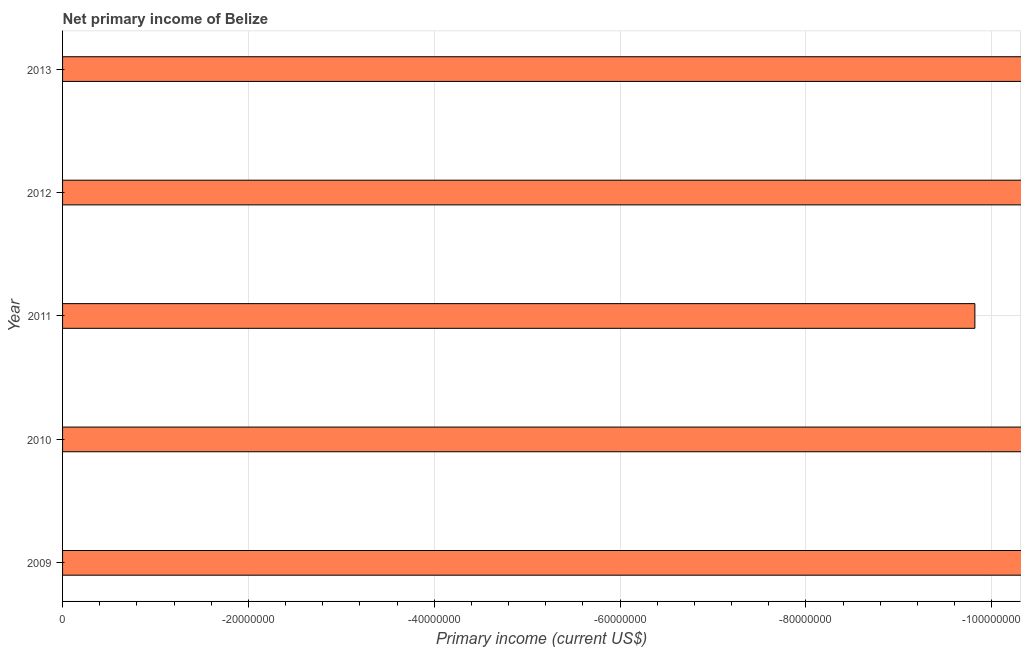Does the graph contain any zero values?
Your answer should be very brief. Yes. What is the title of the graph?
Provide a succinct answer. Net primary income of Belize. What is the label or title of the X-axis?
Your answer should be compact. Primary income (current US$). Across all years, what is the minimum amount of primary income?
Keep it short and to the point. 0. What is the sum of the amount of primary income?
Your answer should be compact. 0. In how many years, is the amount of primary income greater than -84000000 US$?
Your answer should be very brief. 0. In how many years, is the amount of primary income greater than the average amount of primary income taken over all years?
Provide a short and direct response. 0. Are all the bars in the graph horizontal?
Keep it short and to the point. Yes. What is the difference between two consecutive major ticks on the X-axis?
Provide a short and direct response. 2.00e+07. Are the values on the major ticks of X-axis written in scientific E-notation?
Keep it short and to the point. No. What is the Primary income (current US$) of 2009?
Give a very brief answer. 0. What is the Primary income (current US$) of 2013?
Your answer should be very brief. 0. 